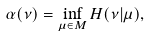Convert formula to latex. <formula><loc_0><loc_0><loc_500><loc_500>\alpha ( \nu ) = \inf _ { \mu \in M } H ( \nu | \mu ) ,</formula> 